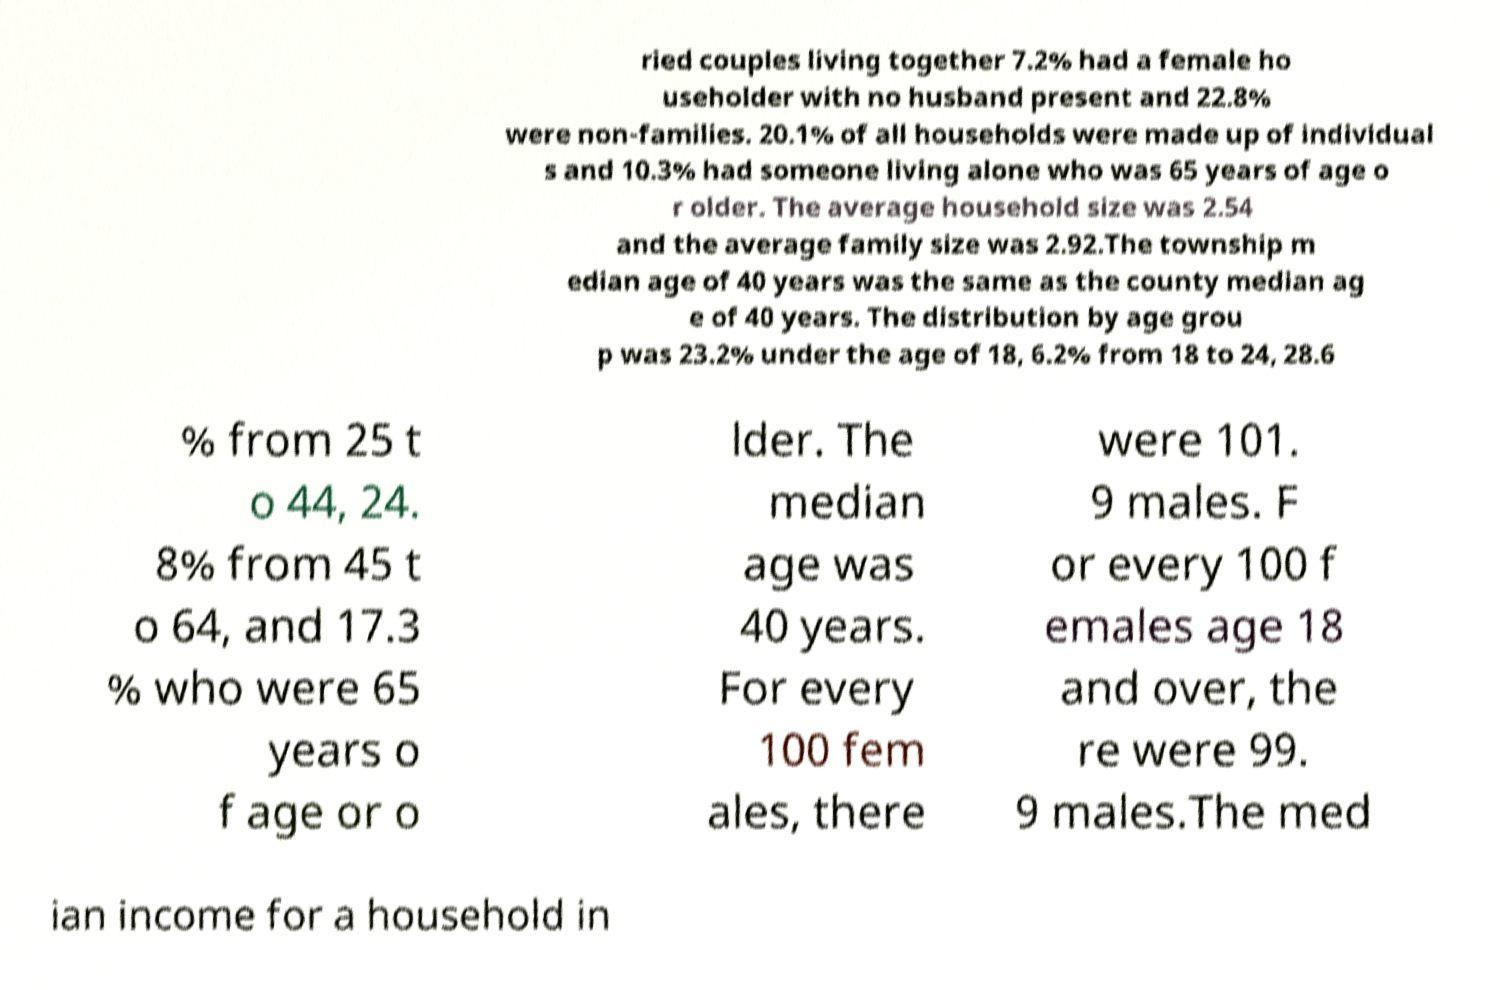For documentation purposes, I need the text within this image transcribed. Could you provide that? ried couples living together 7.2% had a female ho useholder with no husband present and 22.8% were non-families. 20.1% of all households were made up of individual s and 10.3% had someone living alone who was 65 years of age o r older. The average household size was 2.54 and the average family size was 2.92.The township m edian age of 40 years was the same as the county median ag e of 40 years. The distribution by age grou p was 23.2% under the age of 18, 6.2% from 18 to 24, 28.6 % from 25 t o 44, 24. 8% from 45 t o 64, and 17.3 % who were 65 years o f age or o lder. The median age was 40 years. For every 100 fem ales, there were 101. 9 males. F or every 100 f emales age 18 and over, the re were 99. 9 males.The med ian income for a household in 